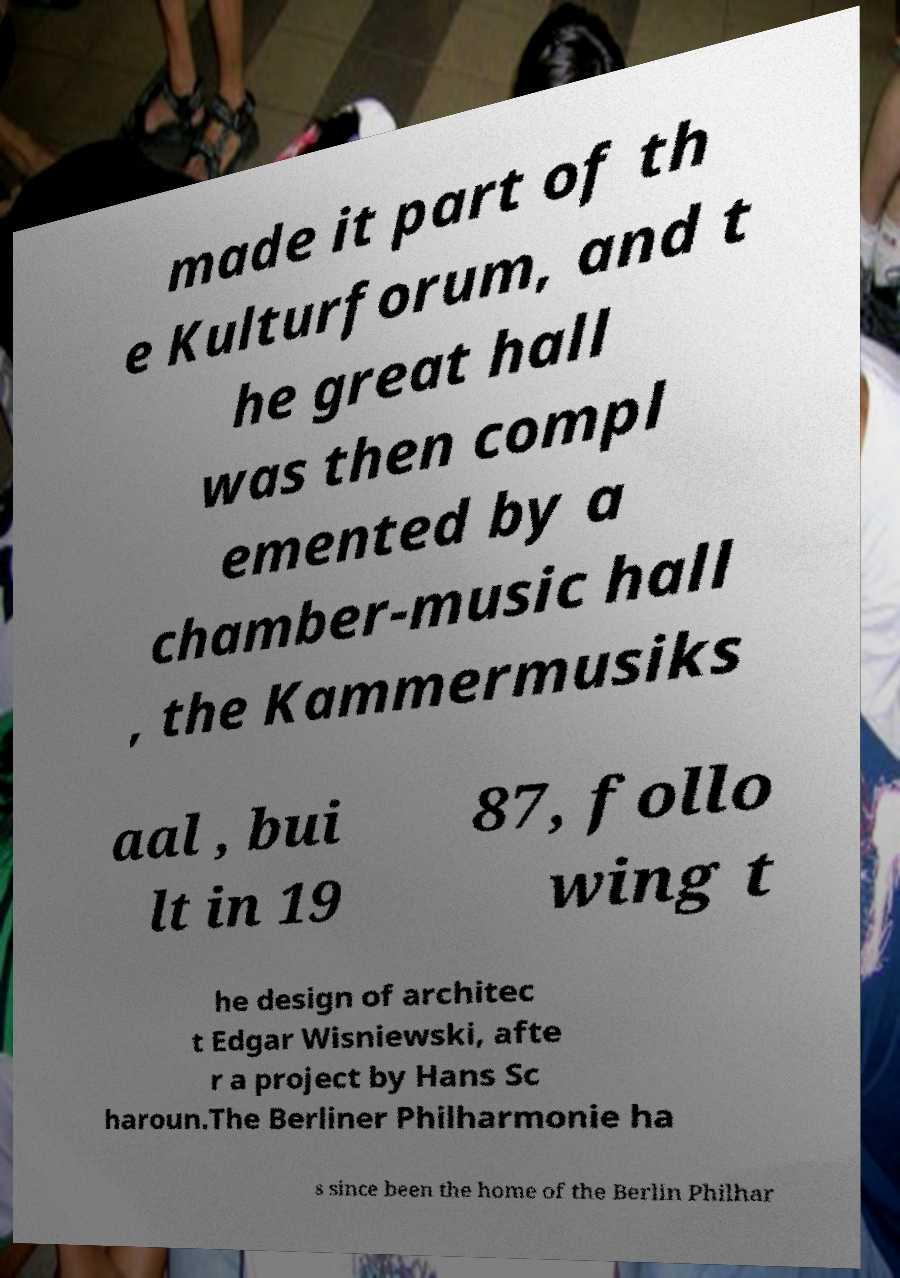Can you accurately transcribe the text from the provided image for me? made it part of th e Kulturforum, and t he great hall was then compl emented by a chamber-music hall , the Kammermusiks aal , bui lt in 19 87, follo wing t he design of architec t Edgar Wisniewski, afte r a project by Hans Sc haroun.The Berliner Philharmonie ha s since been the home of the Berlin Philhar 